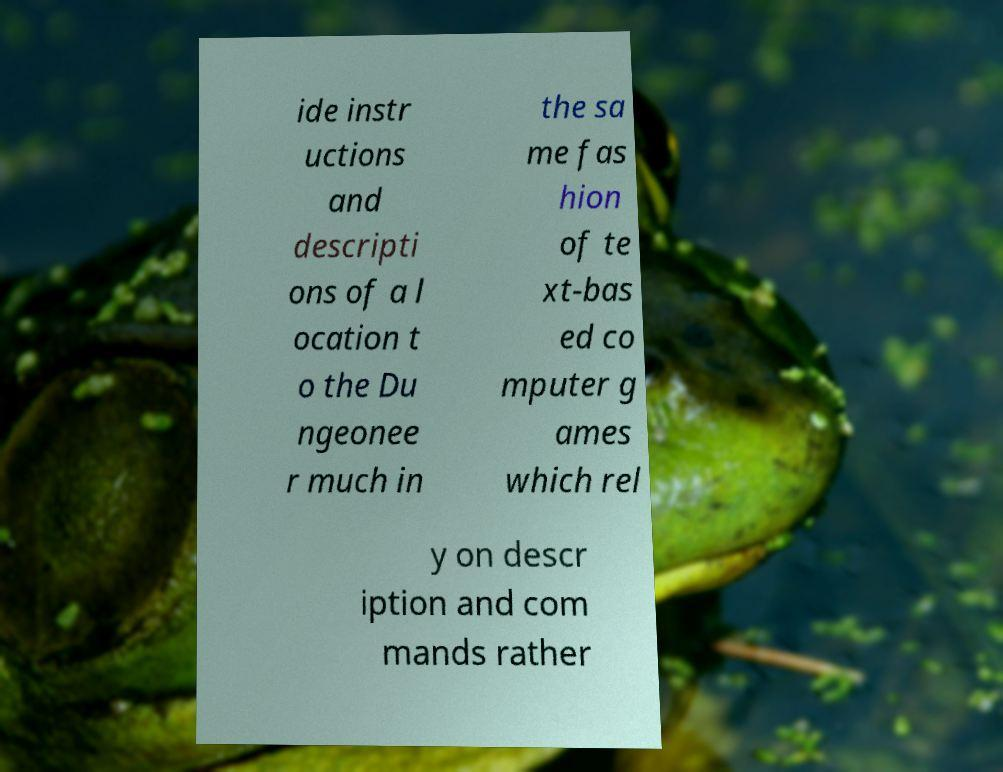Could you assist in decoding the text presented in this image and type it out clearly? ide instr uctions and descripti ons of a l ocation t o the Du ngeonee r much in the sa me fas hion of te xt-bas ed co mputer g ames which rel y on descr iption and com mands rather 